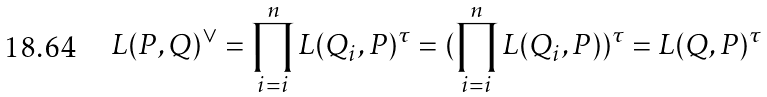Convert formula to latex. <formula><loc_0><loc_0><loc_500><loc_500>L ( P , Q ) ^ { \vee } = \prod _ { i = i } ^ { n } L ( Q _ { i } , P ) ^ { \tau } = ( \prod _ { i = i } ^ { n } L ( Q _ { i } , P ) ) ^ { \tau } = L ( Q , P ) ^ { \tau }</formula> 